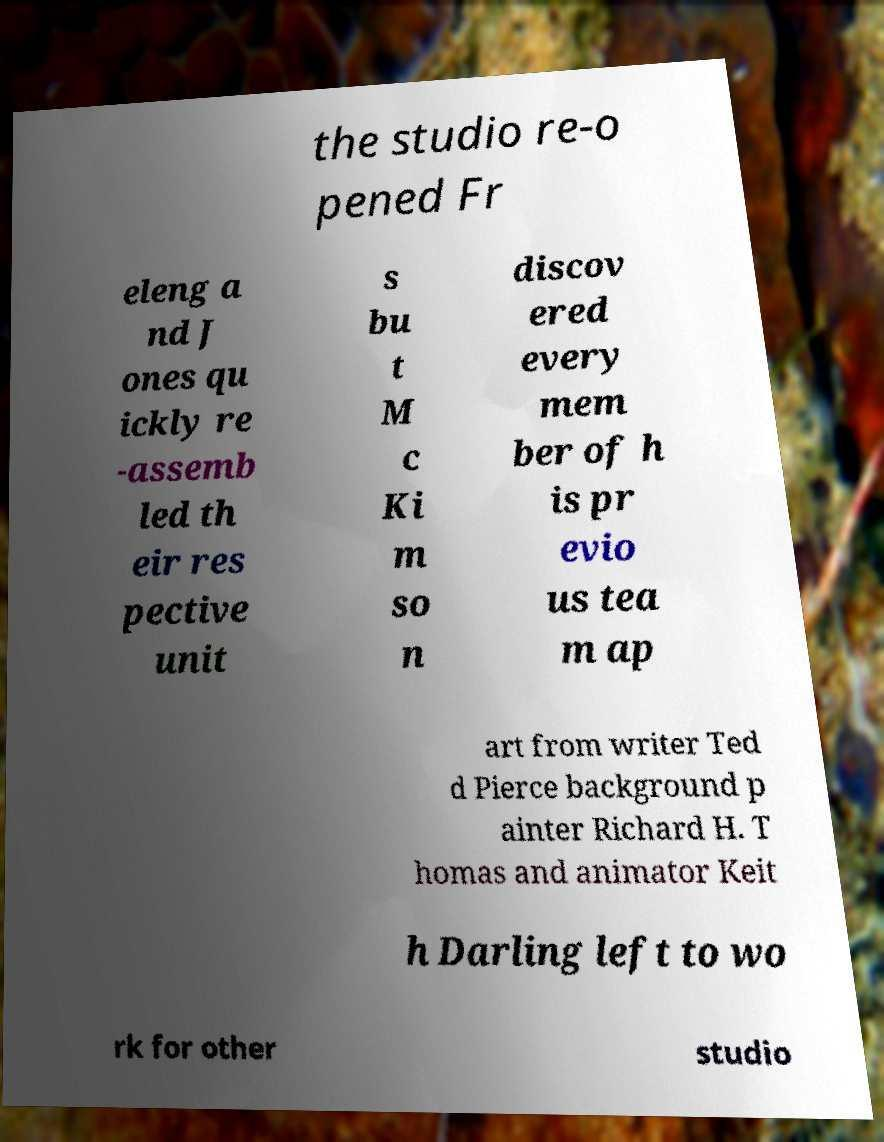I need the written content from this picture converted into text. Can you do that? the studio re-o pened Fr eleng a nd J ones qu ickly re -assemb led th eir res pective unit s bu t M c Ki m so n discov ered every mem ber of h is pr evio us tea m ap art from writer Ted d Pierce background p ainter Richard H. T homas and animator Keit h Darling left to wo rk for other studio 